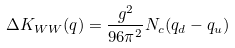<formula> <loc_0><loc_0><loc_500><loc_500>\Delta K _ { W W } ( q ) = \frac { g ^ { 2 } } { 9 6 \pi ^ { 2 } } N _ { c } ( q _ { d } - q _ { u } )</formula> 